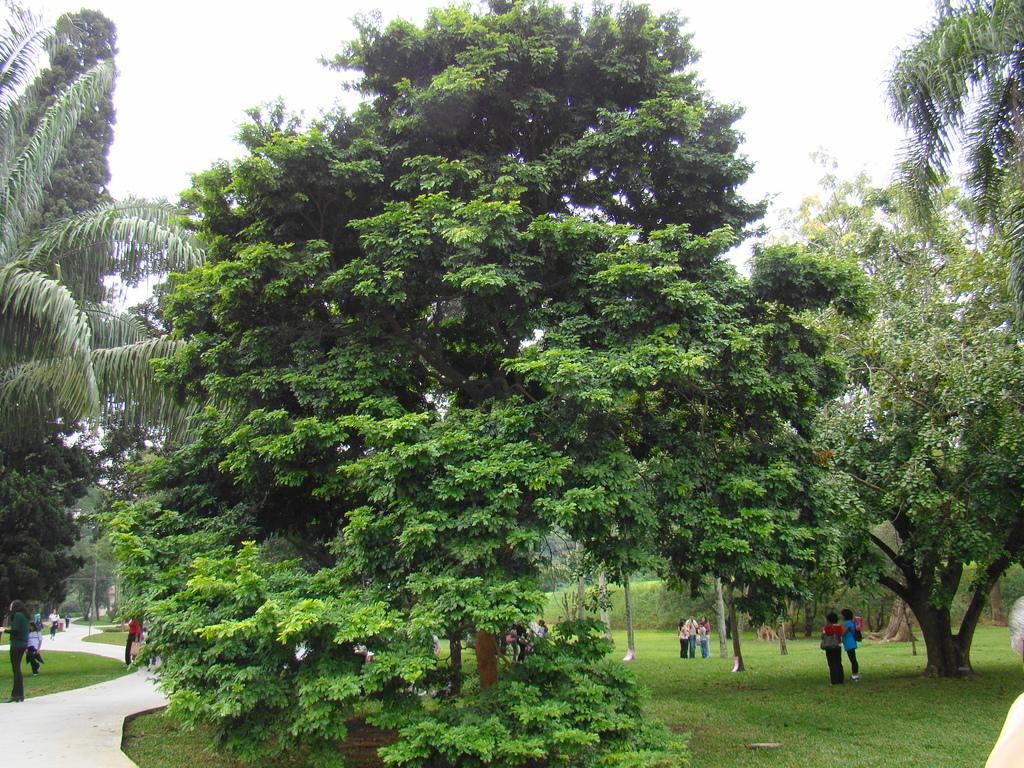What are the people in the image doing? The group of people is standing on the ground. What can be seen in the background of the image? There are trees visible in the image. What is visible above the people and trees in the image? The sky is visible in the image. What type of eggnog is being served to the owl in the image? There is no eggnog or owl present in the image. 